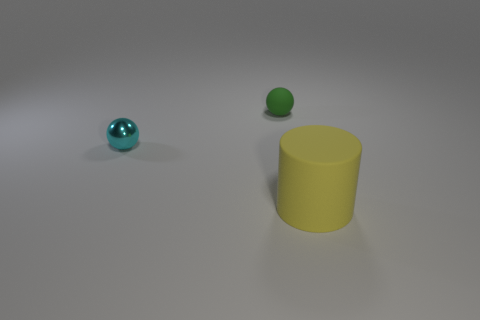How many objects are both to the right of the cyan metallic sphere and left of the large matte cylinder?
Your answer should be compact. 1. How many other things are there of the same color as the tiny matte ball?
Make the answer very short. 0. What shape is the matte object behind the yellow rubber cylinder?
Offer a very short reply. Sphere. Do the cyan ball and the big yellow cylinder have the same material?
Keep it short and to the point. No. Is there anything else that is the same size as the cylinder?
Your response must be concise. No. There is a small green sphere; what number of spheres are behind it?
Ensure brevity in your answer.  0. What shape is the matte thing that is in front of the matte thing behind the big yellow object?
Make the answer very short. Cylinder. Is there any other thing that is the same shape as the metal thing?
Offer a very short reply. Yes. Is the number of rubber objects that are behind the green object greater than the number of yellow rubber things?
Give a very brief answer. No. How many large cylinders are in front of the rubber object to the left of the large matte cylinder?
Give a very brief answer. 1. 